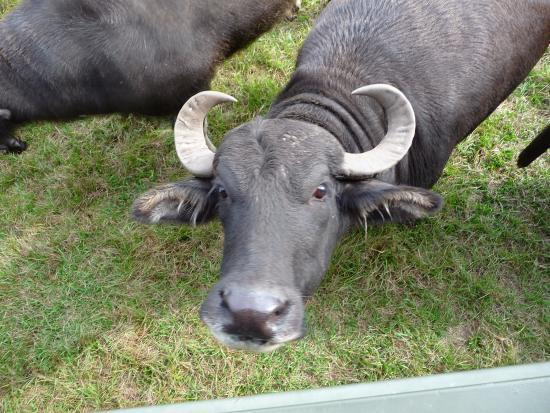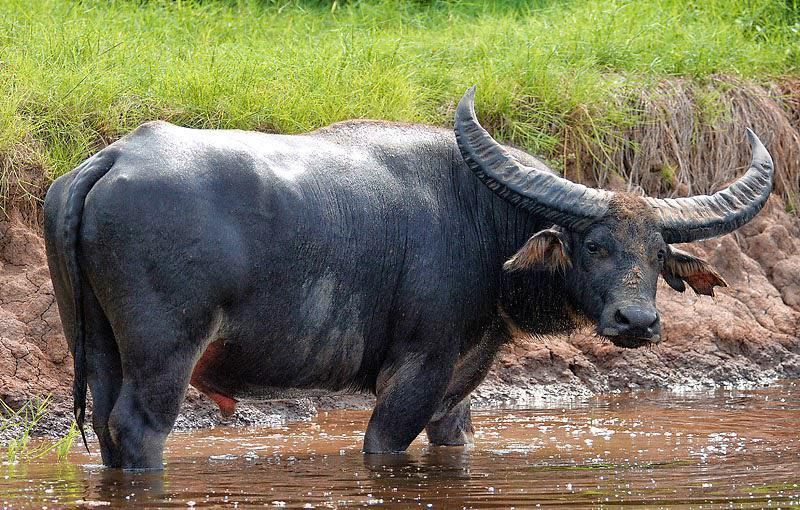The first image is the image on the left, the second image is the image on the right. Assess this claim about the two images: "The left image shows a horned animal in water up to its chest, and the right image shows a buffalo on dry ground.". Correct or not? Answer yes or no. No. 